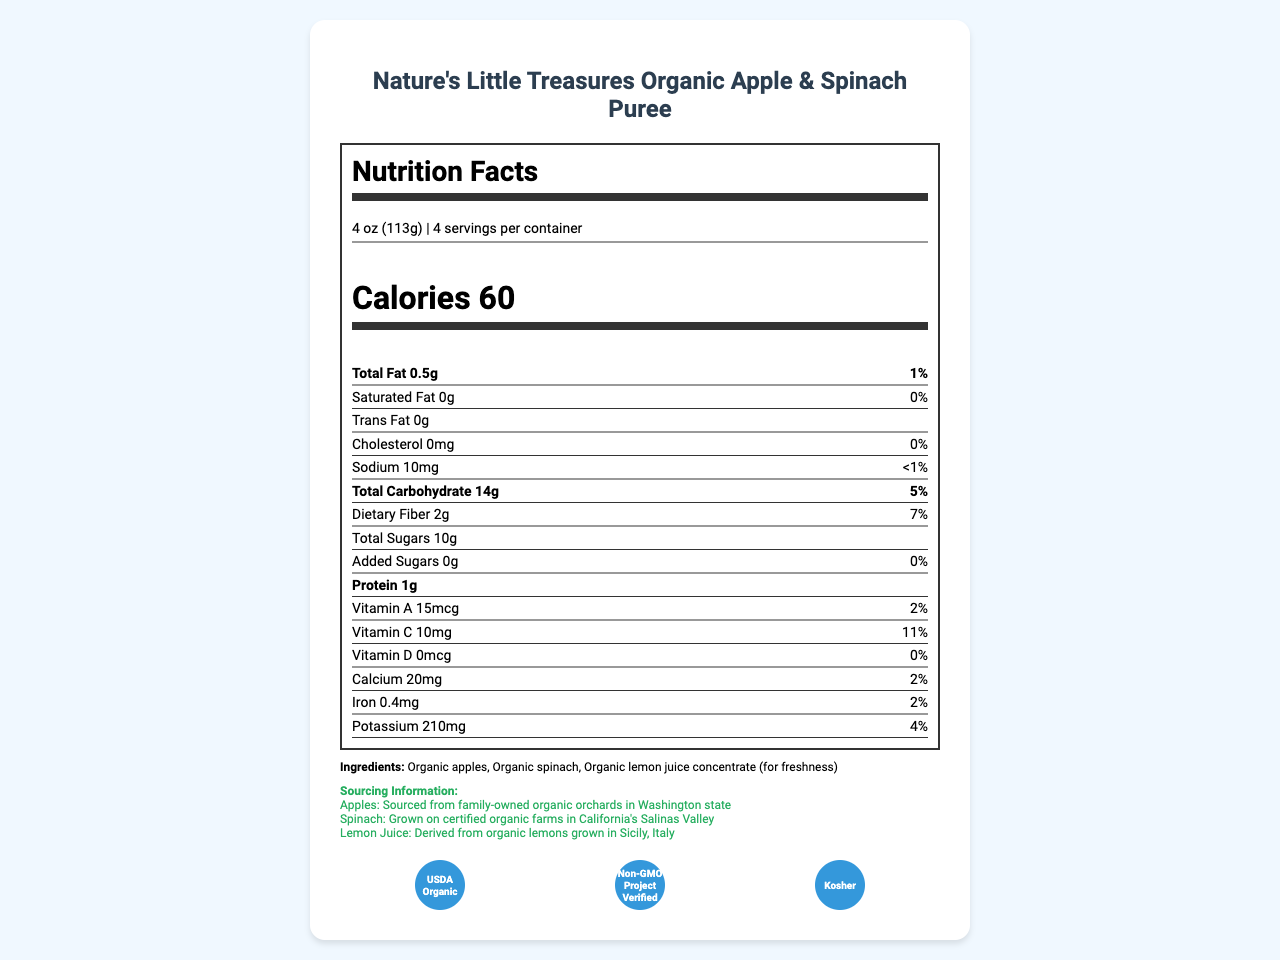What is the serving size of the product? The serving size is listed as "4 oz (113g)" in the serving information.
Answer: 4 oz (113g) What are the main ingredients in the puree? The ingredients are explicitly mentioned under the "Ingredients" section.
Answer: Organic apples, Organic spinach, Organic lemon juice concentrate (for freshness) How many calories are in one serving? The calories per serving are stated clearly as 60 in the document.
Answer: 60 What is the total fat content per serving? The total fat content per serving is listed as "0.5g" under the nutrient section.
Answer: 0.5g What is the percent daily value of Vitamin C per serving? The percent daily value of Vitamin C is listed as "11%" next to the Vitamin C amount.
Answer: 11% Does the product contain any added sugars? The document states that the amount of added sugars is "0g" with a daily value of "0%".
Answer: No What is the shelf life of the product? The product's shelf life is mentioned as "18 months from date of manufacture".
Answer: 18 months from date of manufacture Where are the apples sourced from? The sourcing information specifies that the apples are sourced from family-owned organic orchards in Washington state.
Answer: Family-owned organic orchards in Washington state What certifications does the product have? The certifications are listed under the "Certifications" section and include USDA Organic, Non-GMO Project Verified, and Kosher.
Answer: USDA Organic, Non-GMO Project Verified, Kosher Is the product suitable for babies under 6 months old? The document states the target age as "Suitable for babies 6 months and older".
Answer: No What is the product packaging made of? The packaging is described as "BPA-free, recyclable glass jars with tamper-evident safety button".
Answer: BPA-free, recyclable glass jars with tamper-evident safety button The document states that the sodium content is less than 1% of the daily value. What is the actual milligram amount? The actual sodium amount listed is "10mg".
Answer: 10mg Which of the following is NOT an ingredient in the product? A. Organic apples B. Organic spinach C. Organic carrots D. Organic lemon juice concentrate The ingredients listed are Organic apples, Organic spinach, and Organic lemon juice concentrate, with no mention of Organic carrots.
Answer: C. Organic carrots Where is the manufacturing facility located? A. California B. Vermont C. Washington D. New York The document mentions that the product is manufactured in a state-of-the-art facility in Vermont, USA.
Answer: B. Vermont Is the document related to a product line meant for adult consumption? The product is specifically for babies, as mentioned in the target age section.
Answer: No Summarize the main idea of the document. The document provides comprehensive details about Nature's Little Treasures Organic Apple & Spinach Puree, including its ingredients, nutritional values, certifications, sourcing, packaging, and manufacturing, emphasizing its suitability for babies and commitment to sustainability and nutrition.
Answer: Nature's Little Treasures Organic Apple & Spinach Puree is a premium organic baby food product made with high-quality ingredients and detailed sourcing information. It features a nutrition facts label, allergen information, certifications, packaging details, and manufacturing location. It is intended for babies 6 months and older and supports sustainable agriculture and early childhood nutrition programs. How many different nutrients with their respective percentage of daily values are listed on the label? The label lists the percentage of daily values for Total Fat, Saturated Fat, Cholesterol, Sodium, Total Carbohydrate, Dietary Fiber, Vitamin A, Vitamin C, Calcium, and Iron, totaling 8 nutrients.
Answer: 8 What is the commitment of the company stated in the document? There is no explicit section labeled "company commitment" mentioned in the provided data visible in the document screenshot.
Answer: Cannot be determined 